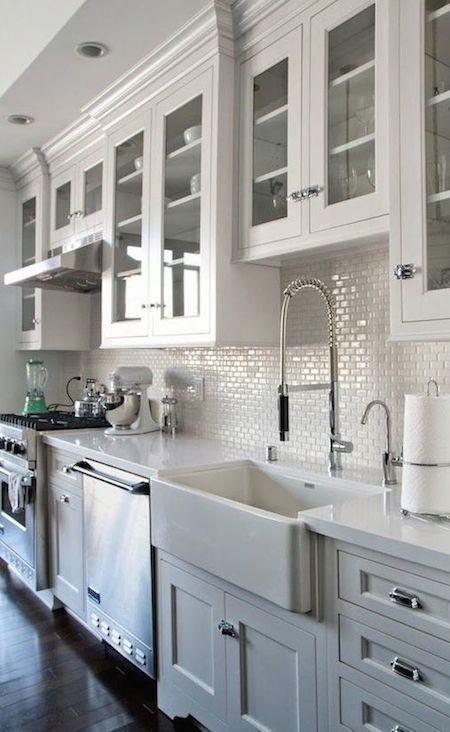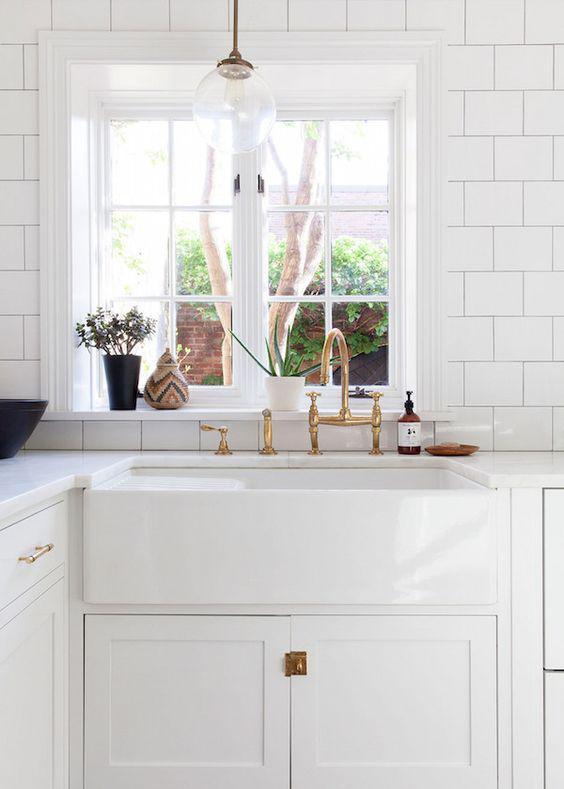The first image is the image on the left, the second image is the image on the right. Given the left and right images, does the statement "An island with a white counter sits in the middle of a kitchen." hold true? Answer yes or no. No. The first image is the image on the left, the second image is the image on the right. Assess this claim about the two images: "In one image, a stainless steel kitchen sink with arc spout is set on a white base cabinet.". Correct or not? Answer yes or no. No. 